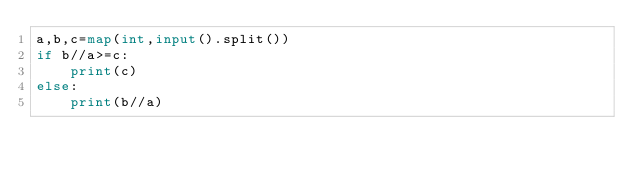<code> <loc_0><loc_0><loc_500><loc_500><_Python_>a,b,c=map(int,input().split())
if b//a>=c:
    print(c)
else:
    print(b//a)</code> 